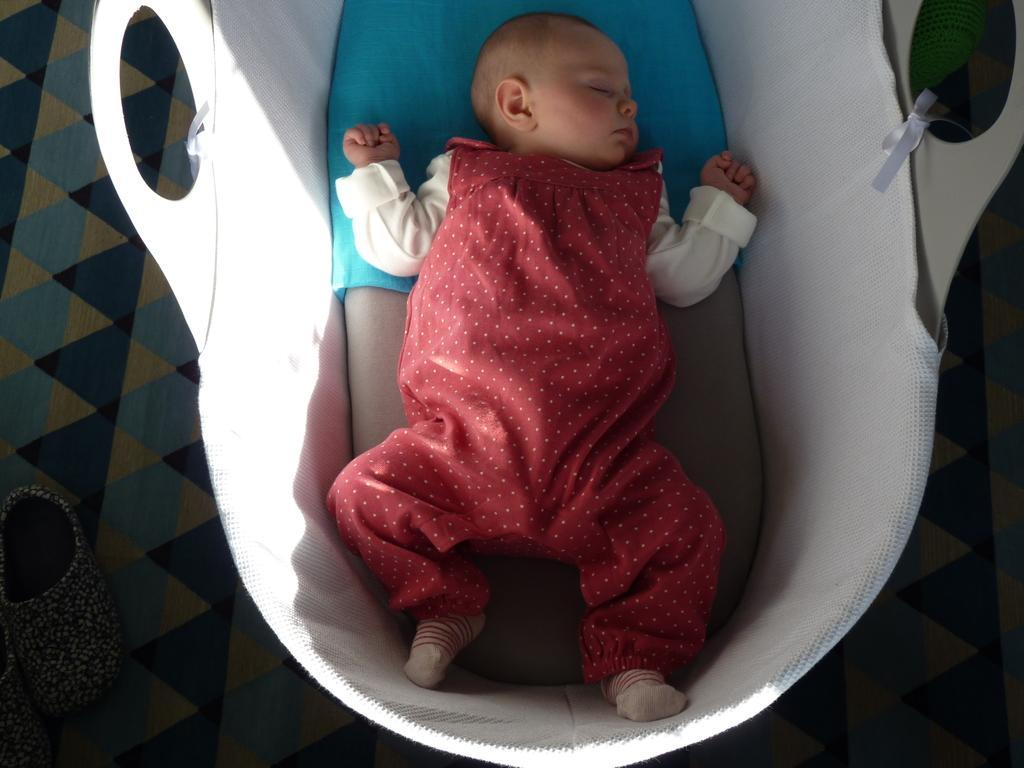Could you give a brief overview of what you see in this image? In the image we can see a baby sleeping and the baby is wearing clothes. Here we can see the basket, floor and the shoes. 